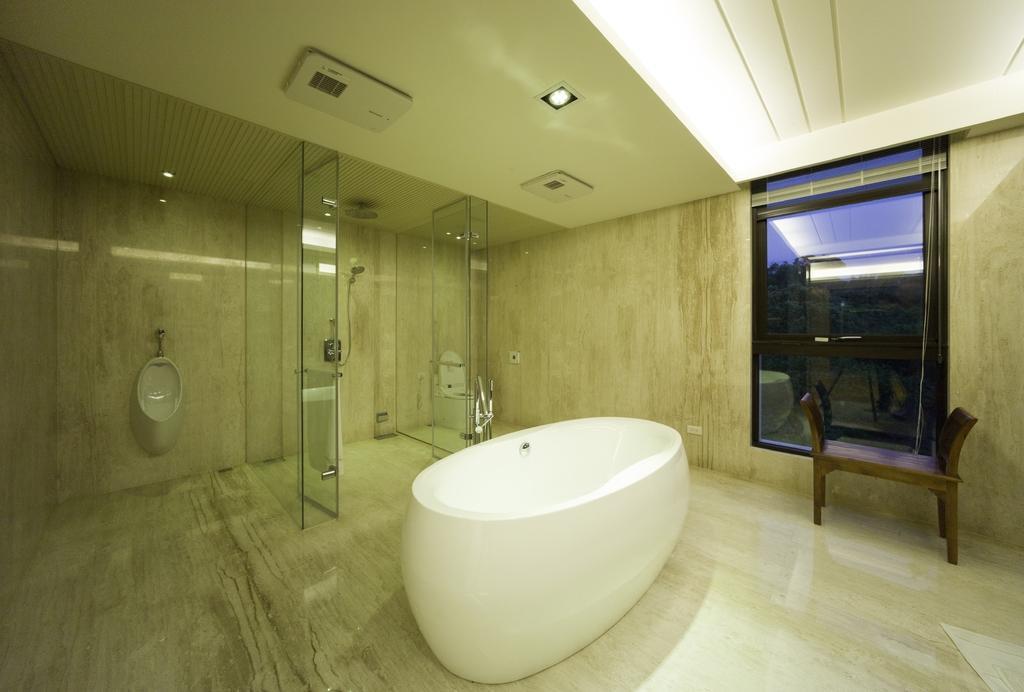Describe this image in one or two sentences. In this picture we can see a bathtub on the floor, bench, toilets, walls, ceiling, window and some objects. In the background we can see trees and the sky. 